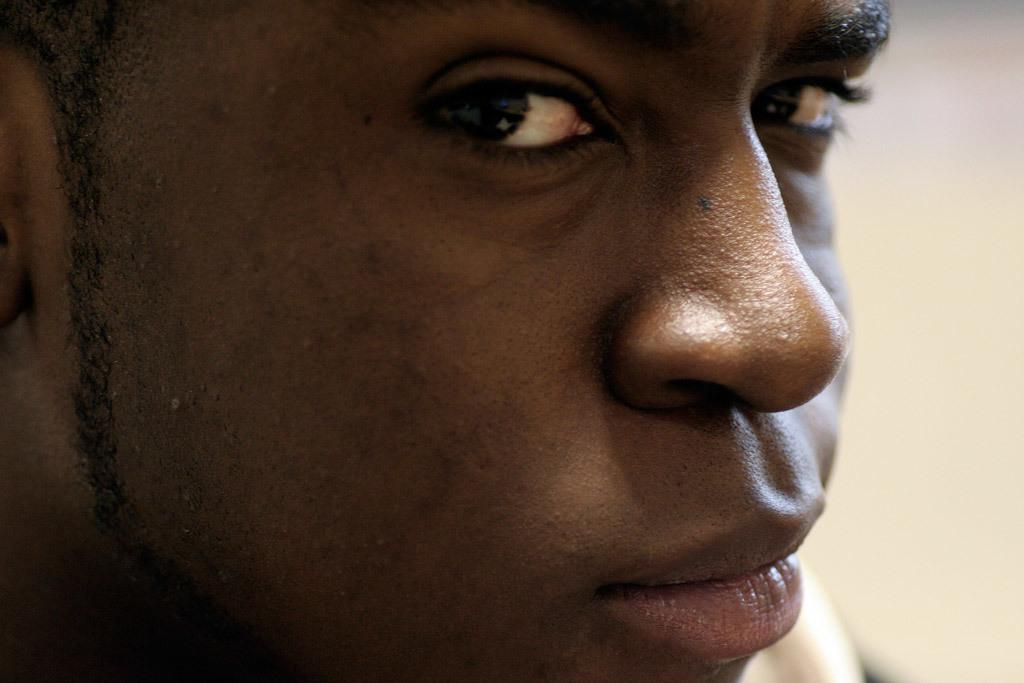What is the main subject of the image? There is a person in the image. What type of pest can be seen crawling on the person in the image? There is no pest present in the image; it only features a person. Is the person holding an umbrella in the image? The provided facts do not mention an umbrella, so we cannot determine if the person is holding one. Can you tell me how many soldiers are present in the image? There is no mention of an army or soldiers in the image; it only features a person. 